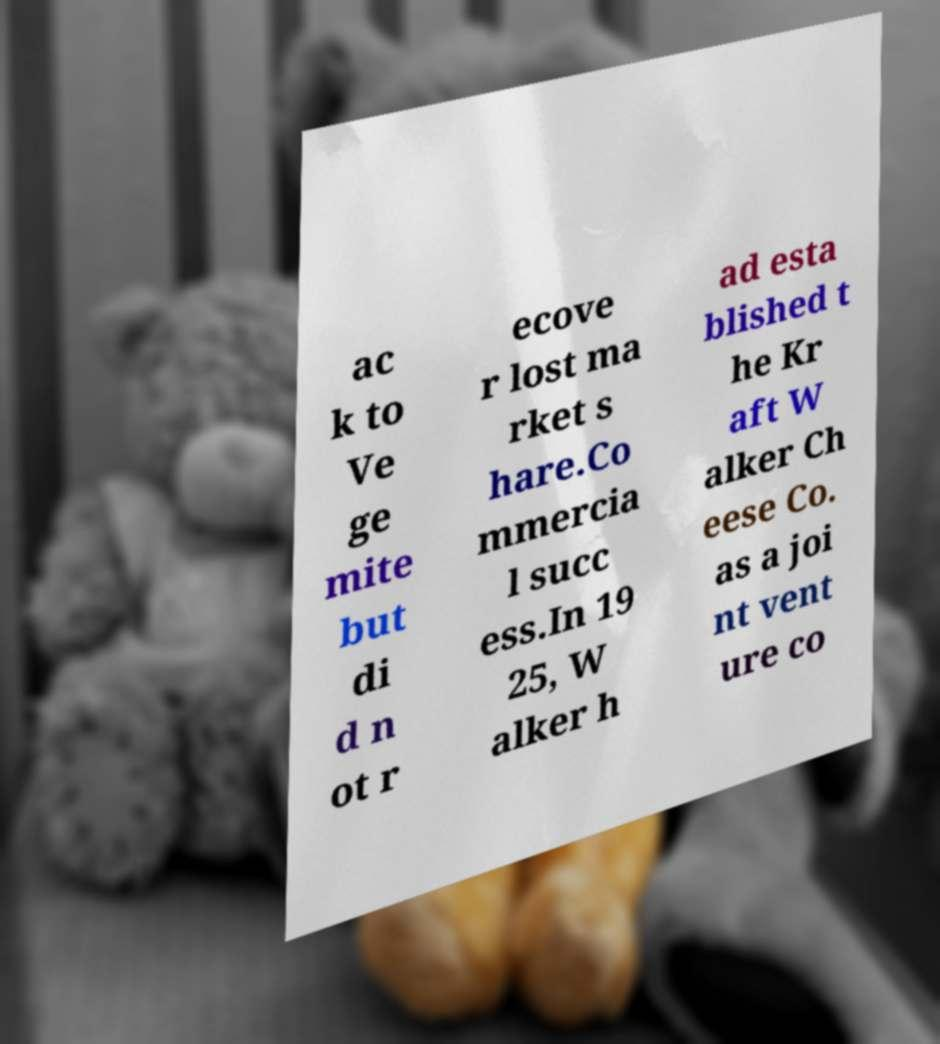For documentation purposes, I need the text within this image transcribed. Could you provide that? ac k to Ve ge mite but di d n ot r ecove r lost ma rket s hare.Co mmercia l succ ess.In 19 25, W alker h ad esta blished t he Kr aft W alker Ch eese Co. as a joi nt vent ure co 